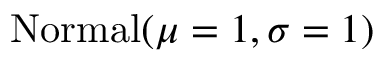Convert formula to latex. <formula><loc_0><loc_0><loc_500><loc_500>N o r m a l ( \mu = 1 , \sigma = 1 )</formula> 